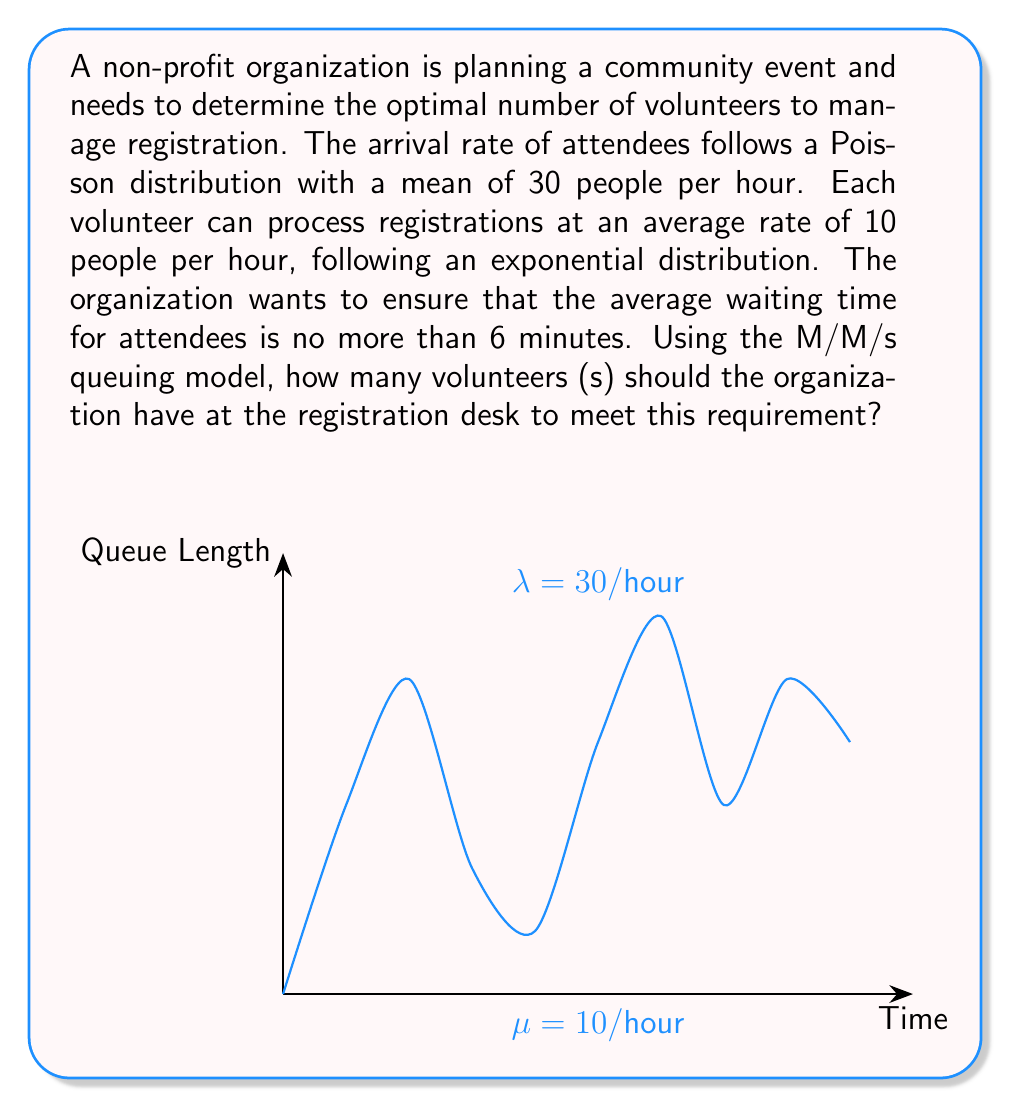Could you help me with this problem? Let's solve this problem step-by-step using the M/M/s queuing model:

1) Given:
   - Arrival rate (λ) = 30 people/hour
   - Service rate per volunteer (μ) = 10 people/hour
   - Maximum average waiting time (Wq) = 6 minutes = 0.1 hours

2) The M/M/s model formula for average waiting time is:

   $$W_q = \frac{P_0 (\lambda/\mu)^s}{s! s\mu(1-\rho)} \cdot \frac{1}{\mu}$$

   where $\rho = \frac{\lambda}{s\mu}$ and $P_0$ is the probability of an empty system.

3) We need to find the smallest value of s that satisfies $W_q \leq 0.1$.

4) Let's start with s = 3:

   $\rho = \frac{30}{3 \cdot 10} = 1$ (This is unstable as $\rho$ should be < 1)

5) Try s = 4:

   $\rho = \frac{30}{4 \cdot 10} = 0.75$

   $P_0 = [\sum_{n=0}^{s-1} \frac{1}{n!} (\frac{\lambda}{\mu})^n + \frac{1}{s!} (\frac{\lambda}{\mu})^s \frac{s\mu}{s\mu - \lambda}]^{-1}$

   $P_0 = [1 + 3 + 4.5 + 4.5 + \frac{4.5 \cdot 4}{4 - 3}]^{-1} = 0.0345$

   $W_q = \frac{0.0345 \cdot (30/10)^4}{4! \cdot 4 \cdot 10 \cdot (1-0.75)} \cdot \frac{1}{10} = 0.1552$ hours

6) This is still greater than 0.1 hours, so let's try s = 5:

   $\rho = \frac{30}{5 \cdot 10} = 0.6$

   $P_0 = [1 + 3 + 4.5 + 4.5 + 3.375 + \frac{3.375 \cdot 5}{5 - 3}]^{-1} = 0.0551$

   $W_q = \frac{0.0551 \cdot (30/10)^5}{5! \cdot 5 \cdot 10 \cdot (1-0.6)} \cdot \frac{1}{10} = 0.0496$ hours

7) This is less than 0.1 hours, so 5 volunteers will be sufficient.
Answer: 5 volunteers 